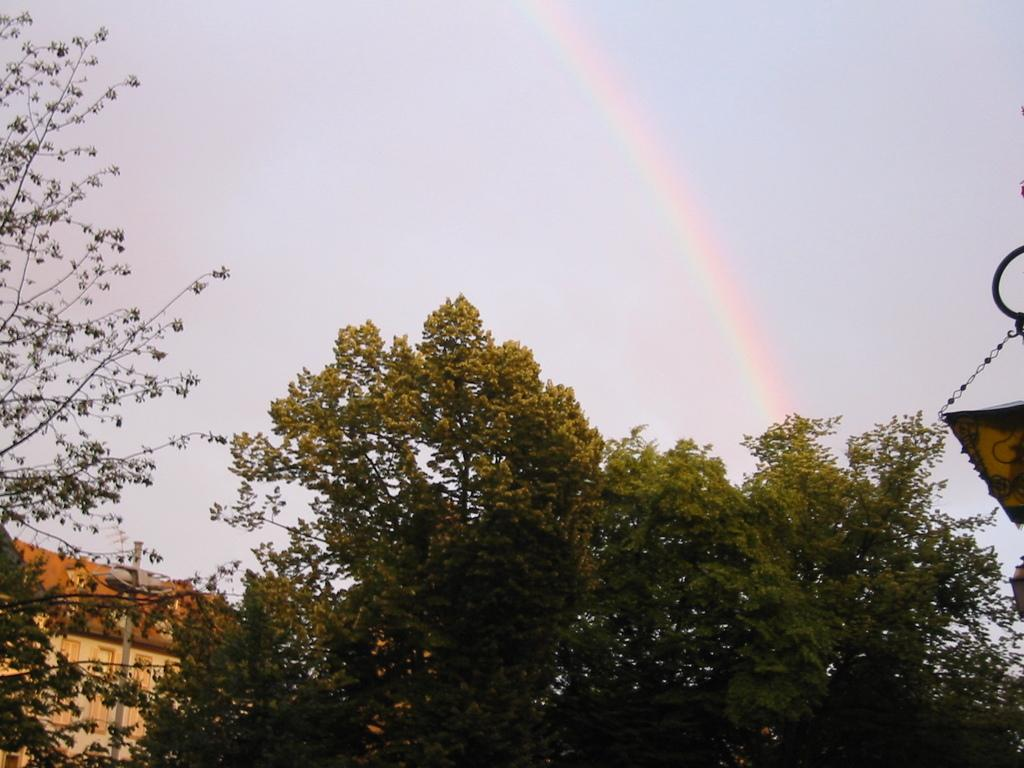What type of vegetation can be seen in the image? There are trees in the image. What is visible in the background of the image? There is a building and the sky visible in the background of the image. What natural phenomenon can be seen in the sky? There is a rainbow in the sky. What type of songs can be heard coming from the volcano in the image? There is no volcano present in the image, so no songs can be heard coming from it. 